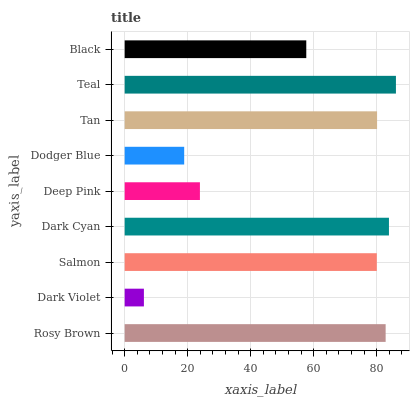Is Dark Violet the minimum?
Answer yes or no. Yes. Is Teal the maximum?
Answer yes or no. Yes. Is Salmon the minimum?
Answer yes or no. No. Is Salmon the maximum?
Answer yes or no. No. Is Salmon greater than Dark Violet?
Answer yes or no. Yes. Is Dark Violet less than Salmon?
Answer yes or no. Yes. Is Dark Violet greater than Salmon?
Answer yes or no. No. Is Salmon less than Dark Violet?
Answer yes or no. No. Is Salmon the high median?
Answer yes or no. Yes. Is Salmon the low median?
Answer yes or no. Yes. Is Dark Violet the high median?
Answer yes or no. No. Is Black the low median?
Answer yes or no. No. 